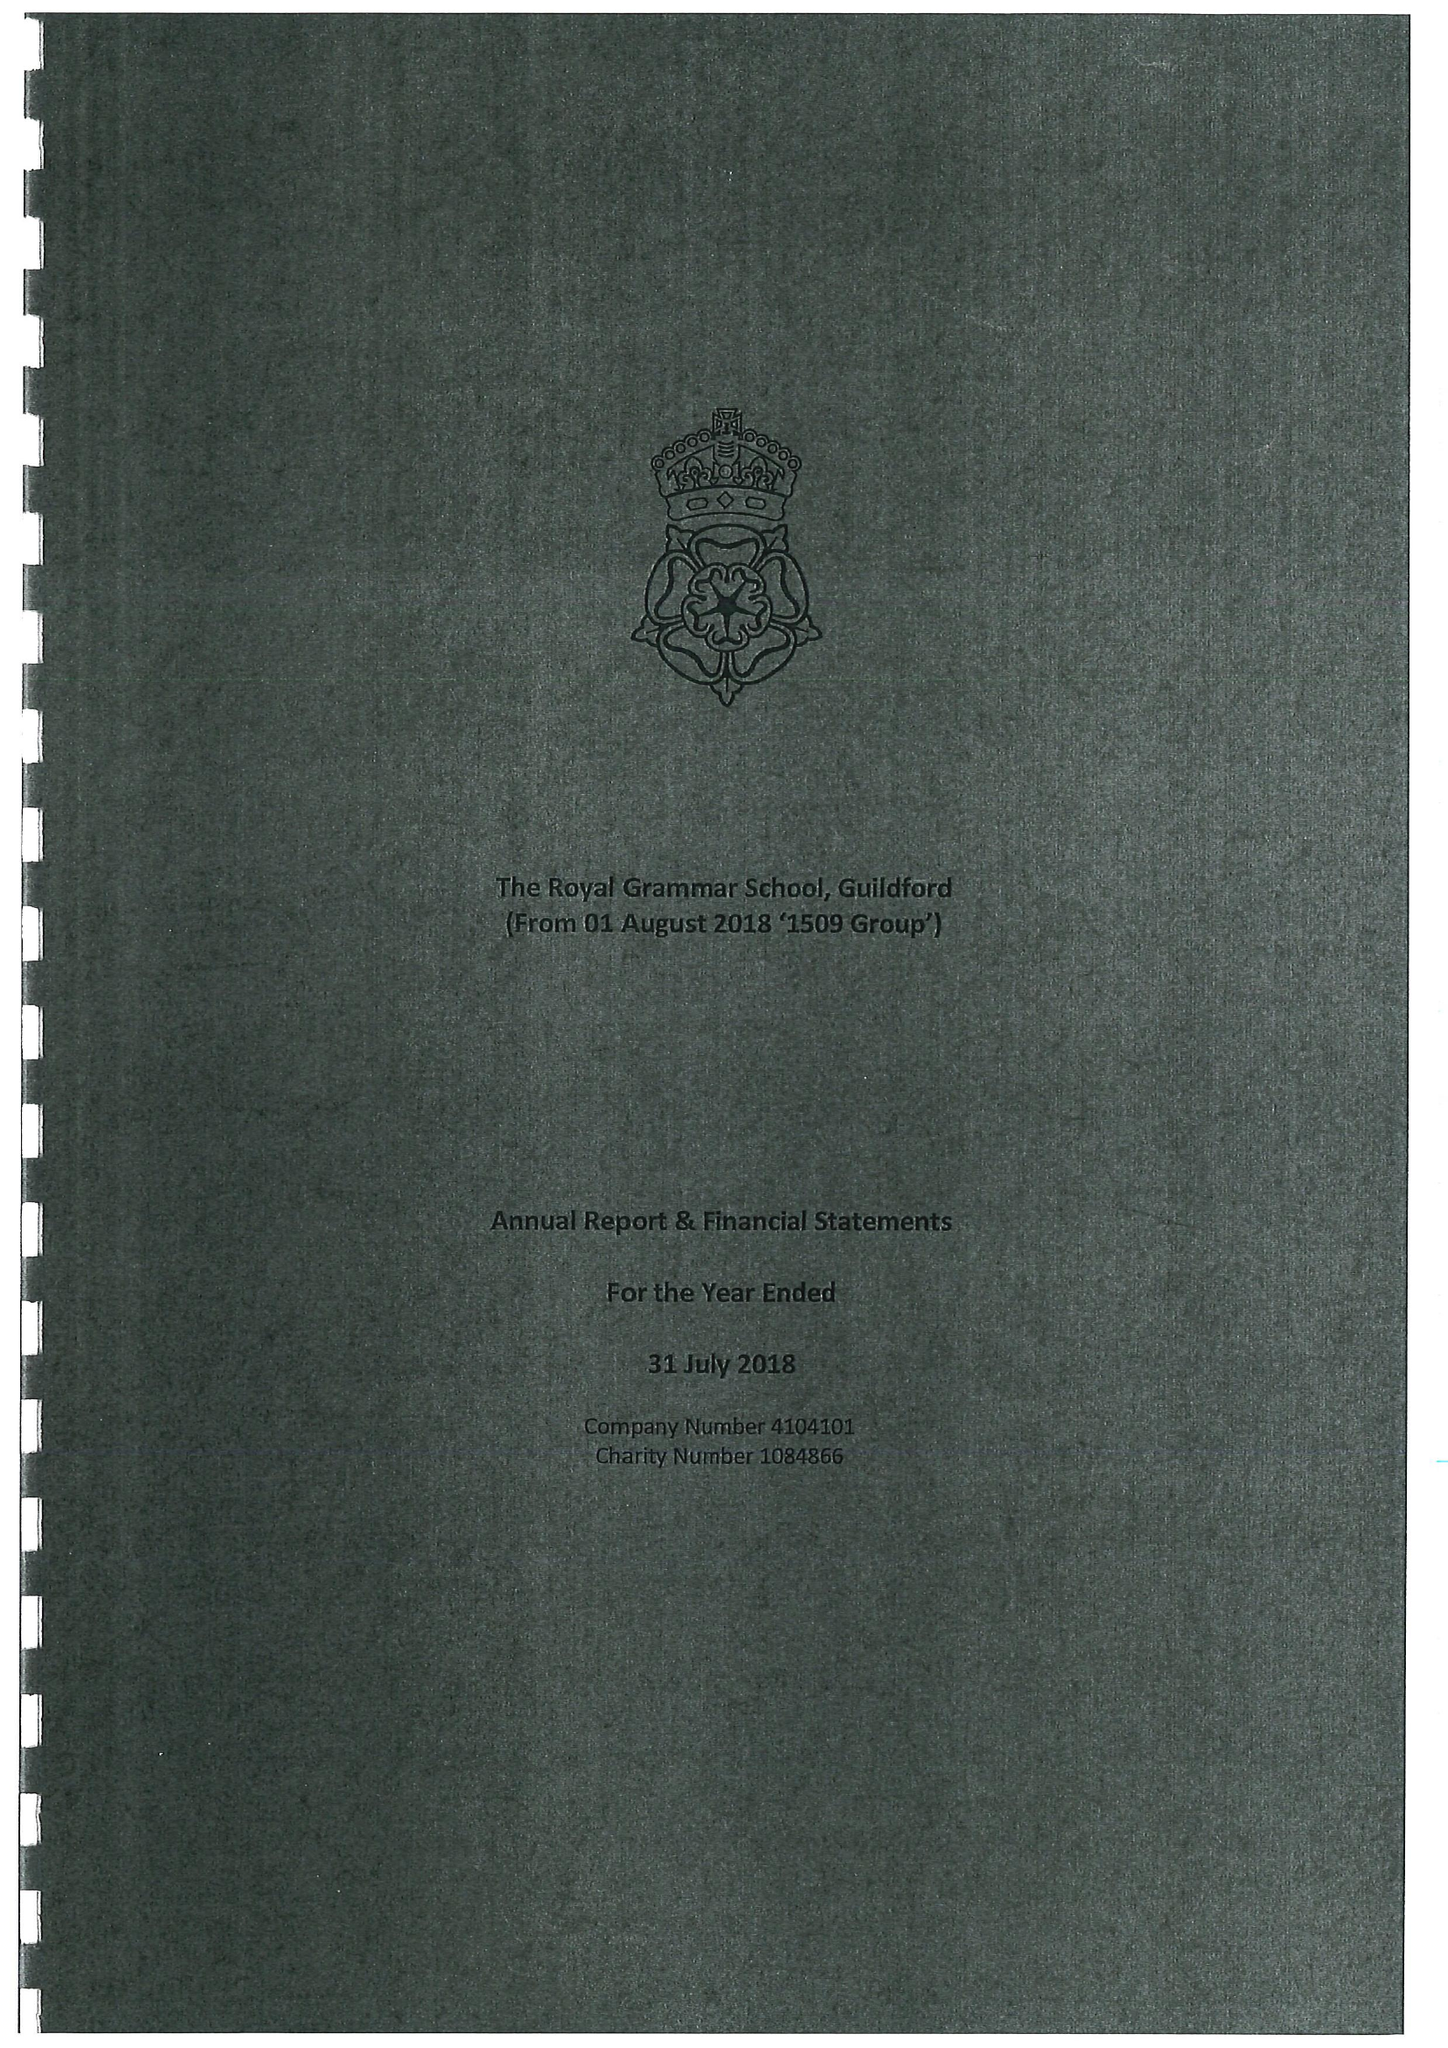What is the value for the income_annually_in_british_pounds?
Answer the question using a single word or phrase. 22646169.00 